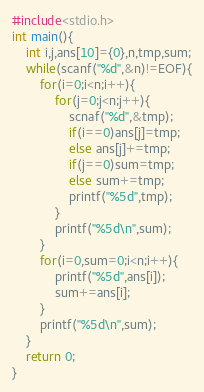Convert code to text. <code><loc_0><loc_0><loc_500><loc_500><_C_>#include<stdio.h>
int main(){
	int i,j,ans[10]={0},n,tmp,sum;
	while(scanf("%d",&n)!=EOF){
		for(i=0;i<n;i++){
			for(j=0;j<n;j++){
				scnaf("%d",&tmp);
				if(i==0)ans[j]=tmp;
				else ans[j]+=tmp;
				if(j==0)sum=tmp;
				else sum+=tmp;
				printf("%5d",tmp);
			}
			printf("%5d\n",sum);
		}
		for(i=0,sum=0;i<n;i++){
			printf("%5d",ans[i]);
			sum+=ans[i];
		}
		printf("%5d\n",sum);
	}
	return 0;
}</code> 